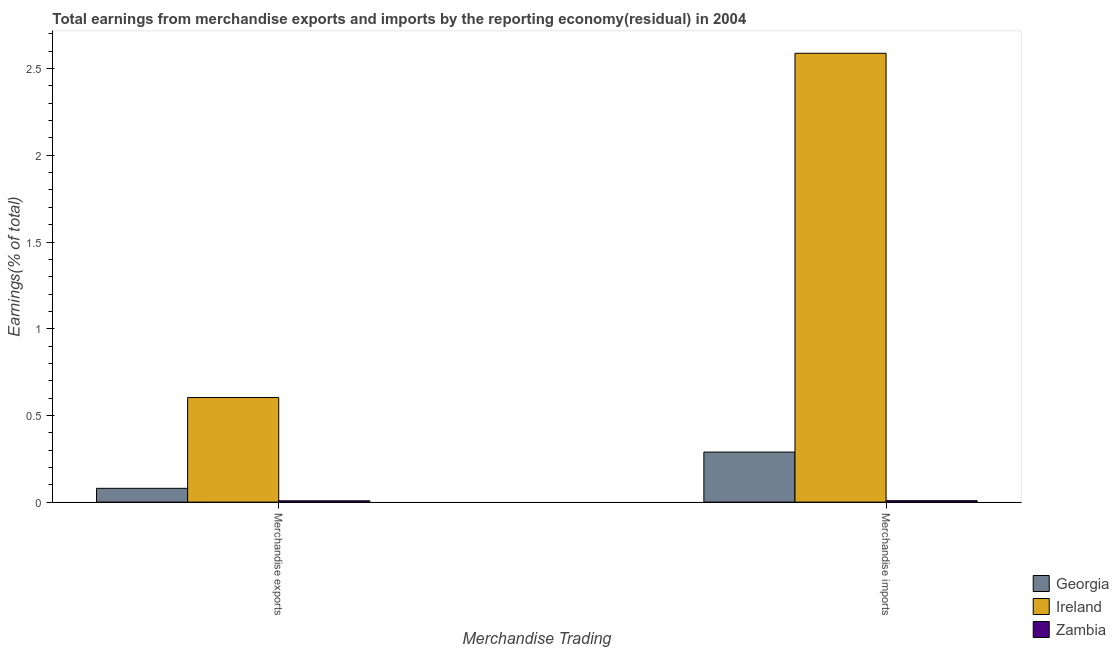How many groups of bars are there?
Keep it short and to the point. 2. Are the number of bars on each tick of the X-axis equal?
Offer a very short reply. Yes. How many bars are there on the 1st tick from the left?
Your response must be concise. 3. How many bars are there on the 2nd tick from the right?
Offer a very short reply. 3. What is the label of the 2nd group of bars from the left?
Offer a terse response. Merchandise imports. What is the earnings from merchandise imports in Ireland?
Provide a short and direct response. 2.59. Across all countries, what is the maximum earnings from merchandise exports?
Your answer should be compact. 0.6. Across all countries, what is the minimum earnings from merchandise exports?
Your answer should be very brief. 0.01. In which country was the earnings from merchandise imports maximum?
Offer a terse response. Ireland. In which country was the earnings from merchandise exports minimum?
Give a very brief answer. Zambia. What is the total earnings from merchandise exports in the graph?
Your answer should be very brief. 0.69. What is the difference between the earnings from merchandise exports in Georgia and that in Zambia?
Provide a short and direct response. 0.07. What is the difference between the earnings from merchandise imports in Zambia and the earnings from merchandise exports in Georgia?
Your response must be concise. -0.07. What is the average earnings from merchandise imports per country?
Provide a succinct answer. 0.96. What is the difference between the earnings from merchandise imports and earnings from merchandise exports in Ireland?
Provide a succinct answer. 1.99. In how many countries, is the earnings from merchandise exports greater than 1.1 %?
Offer a very short reply. 0. What is the ratio of the earnings from merchandise exports in Zambia to that in Ireland?
Give a very brief answer. 0.01. Is the earnings from merchandise imports in Zambia less than that in Ireland?
Provide a succinct answer. Yes. In how many countries, is the earnings from merchandise exports greater than the average earnings from merchandise exports taken over all countries?
Give a very brief answer. 1. What does the 1st bar from the left in Merchandise exports represents?
Make the answer very short. Georgia. What does the 2nd bar from the right in Merchandise exports represents?
Keep it short and to the point. Ireland. How many bars are there?
Make the answer very short. 6. Are the values on the major ticks of Y-axis written in scientific E-notation?
Ensure brevity in your answer.  No. Does the graph contain grids?
Keep it short and to the point. No. Where does the legend appear in the graph?
Provide a succinct answer. Bottom right. What is the title of the graph?
Keep it short and to the point. Total earnings from merchandise exports and imports by the reporting economy(residual) in 2004. Does "Congo (Republic)" appear as one of the legend labels in the graph?
Provide a succinct answer. No. What is the label or title of the X-axis?
Offer a very short reply. Merchandise Trading. What is the label or title of the Y-axis?
Make the answer very short. Earnings(% of total). What is the Earnings(% of total) in Georgia in Merchandise exports?
Ensure brevity in your answer.  0.08. What is the Earnings(% of total) of Ireland in Merchandise exports?
Your answer should be very brief. 0.6. What is the Earnings(% of total) of Zambia in Merchandise exports?
Ensure brevity in your answer.  0.01. What is the Earnings(% of total) in Georgia in Merchandise imports?
Offer a very short reply. 0.29. What is the Earnings(% of total) in Ireland in Merchandise imports?
Provide a succinct answer. 2.59. What is the Earnings(% of total) in Zambia in Merchandise imports?
Ensure brevity in your answer.  0.01. Across all Merchandise Trading, what is the maximum Earnings(% of total) in Georgia?
Offer a very short reply. 0.29. Across all Merchandise Trading, what is the maximum Earnings(% of total) of Ireland?
Your response must be concise. 2.59. Across all Merchandise Trading, what is the maximum Earnings(% of total) in Zambia?
Provide a short and direct response. 0.01. Across all Merchandise Trading, what is the minimum Earnings(% of total) of Georgia?
Keep it short and to the point. 0.08. Across all Merchandise Trading, what is the minimum Earnings(% of total) of Ireland?
Your answer should be compact. 0.6. Across all Merchandise Trading, what is the minimum Earnings(% of total) in Zambia?
Your answer should be very brief. 0.01. What is the total Earnings(% of total) of Georgia in the graph?
Ensure brevity in your answer.  0.37. What is the total Earnings(% of total) of Ireland in the graph?
Your answer should be compact. 3.19. What is the total Earnings(% of total) of Zambia in the graph?
Your answer should be very brief. 0.02. What is the difference between the Earnings(% of total) of Georgia in Merchandise exports and that in Merchandise imports?
Provide a succinct answer. -0.21. What is the difference between the Earnings(% of total) of Ireland in Merchandise exports and that in Merchandise imports?
Offer a terse response. -1.99. What is the difference between the Earnings(% of total) in Zambia in Merchandise exports and that in Merchandise imports?
Ensure brevity in your answer.  -0. What is the difference between the Earnings(% of total) of Georgia in Merchandise exports and the Earnings(% of total) of Ireland in Merchandise imports?
Provide a succinct answer. -2.51. What is the difference between the Earnings(% of total) of Georgia in Merchandise exports and the Earnings(% of total) of Zambia in Merchandise imports?
Ensure brevity in your answer.  0.07. What is the difference between the Earnings(% of total) of Ireland in Merchandise exports and the Earnings(% of total) of Zambia in Merchandise imports?
Make the answer very short. 0.6. What is the average Earnings(% of total) of Georgia per Merchandise Trading?
Offer a very short reply. 0.18. What is the average Earnings(% of total) of Ireland per Merchandise Trading?
Offer a very short reply. 1.6. What is the average Earnings(% of total) in Zambia per Merchandise Trading?
Offer a terse response. 0.01. What is the difference between the Earnings(% of total) in Georgia and Earnings(% of total) in Ireland in Merchandise exports?
Your answer should be compact. -0.52. What is the difference between the Earnings(% of total) of Georgia and Earnings(% of total) of Zambia in Merchandise exports?
Provide a short and direct response. 0.07. What is the difference between the Earnings(% of total) of Ireland and Earnings(% of total) of Zambia in Merchandise exports?
Give a very brief answer. 0.6. What is the difference between the Earnings(% of total) in Georgia and Earnings(% of total) in Ireland in Merchandise imports?
Your answer should be very brief. -2.3. What is the difference between the Earnings(% of total) in Georgia and Earnings(% of total) in Zambia in Merchandise imports?
Your response must be concise. 0.28. What is the difference between the Earnings(% of total) in Ireland and Earnings(% of total) in Zambia in Merchandise imports?
Offer a very short reply. 2.58. What is the ratio of the Earnings(% of total) of Georgia in Merchandise exports to that in Merchandise imports?
Your answer should be very brief. 0.28. What is the ratio of the Earnings(% of total) in Ireland in Merchandise exports to that in Merchandise imports?
Provide a short and direct response. 0.23. What is the ratio of the Earnings(% of total) of Zambia in Merchandise exports to that in Merchandise imports?
Offer a very short reply. 0.94. What is the difference between the highest and the second highest Earnings(% of total) in Georgia?
Keep it short and to the point. 0.21. What is the difference between the highest and the second highest Earnings(% of total) of Ireland?
Give a very brief answer. 1.99. What is the difference between the highest and the lowest Earnings(% of total) in Georgia?
Offer a very short reply. 0.21. What is the difference between the highest and the lowest Earnings(% of total) of Ireland?
Provide a succinct answer. 1.99. 